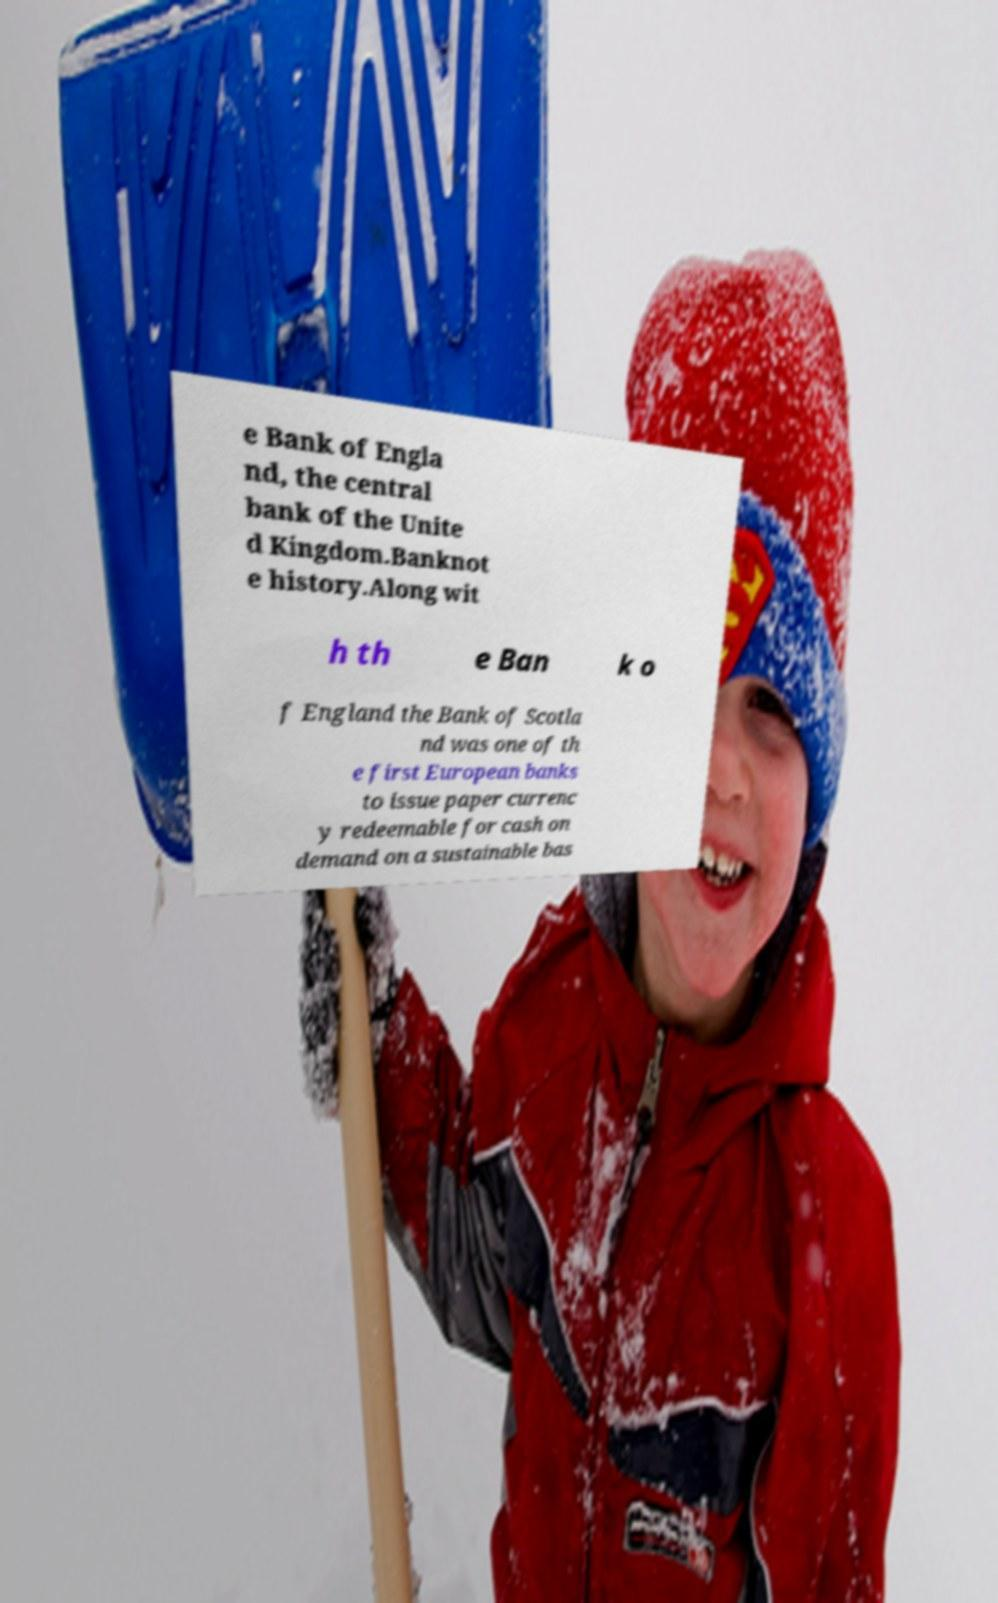Could you extract and type out the text from this image? e Bank of Engla nd, the central bank of the Unite d Kingdom.Banknot e history.Along wit h th e Ban k o f England the Bank of Scotla nd was one of th e first European banks to issue paper currenc y redeemable for cash on demand on a sustainable bas 